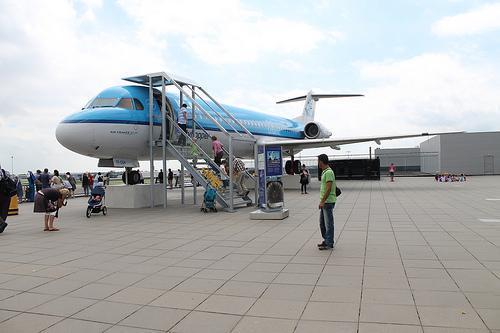How many people are wearing pink shirt?
Give a very brief answer. 1. 